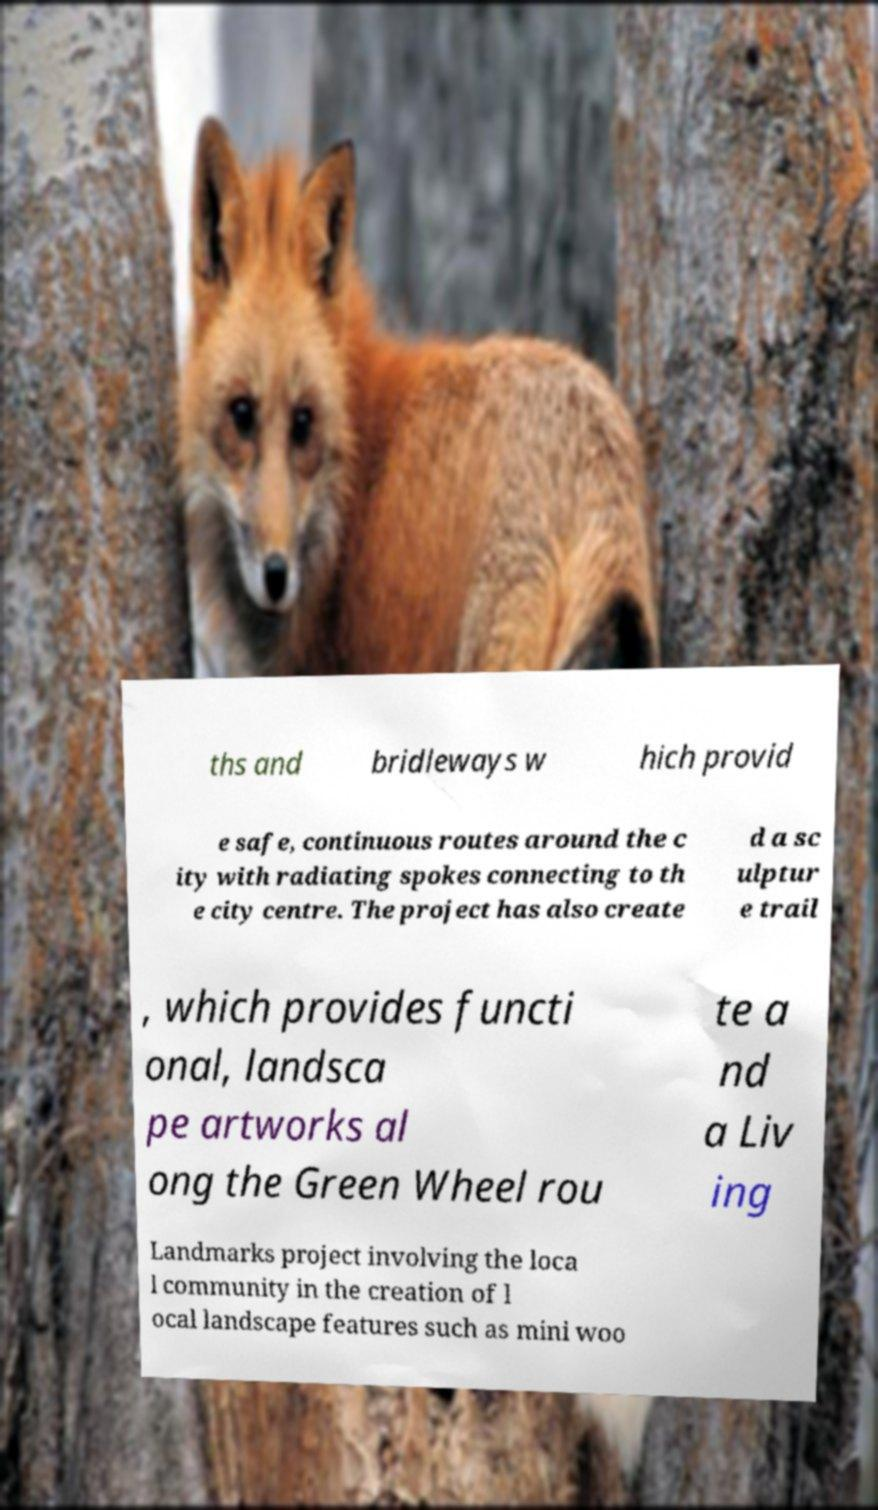I need the written content from this picture converted into text. Can you do that? ths and bridleways w hich provid e safe, continuous routes around the c ity with radiating spokes connecting to th e city centre. The project has also create d a sc ulptur e trail , which provides functi onal, landsca pe artworks al ong the Green Wheel rou te a nd a Liv ing Landmarks project involving the loca l community in the creation of l ocal landscape features such as mini woo 